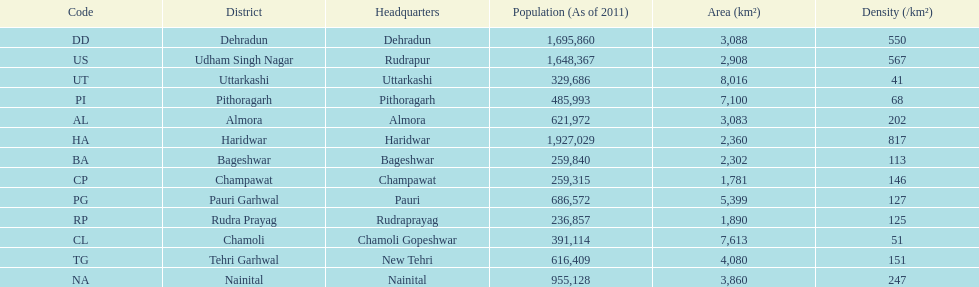What are the names of all the districts? Almora, Bageshwar, Chamoli, Champawat, Dehradun, Haridwar, Nainital, Pauri Garhwal, Pithoragarh, Rudra Prayag, Tehri Garhwal, Udham Singh Nagar, Uttarkashi. What range of densities do these districts encompass? 202, 113, 51, 146, 550, 817, 247, 127, 68, 125, 151, 567, 41. Which district has a density of 51? Chamoli. 